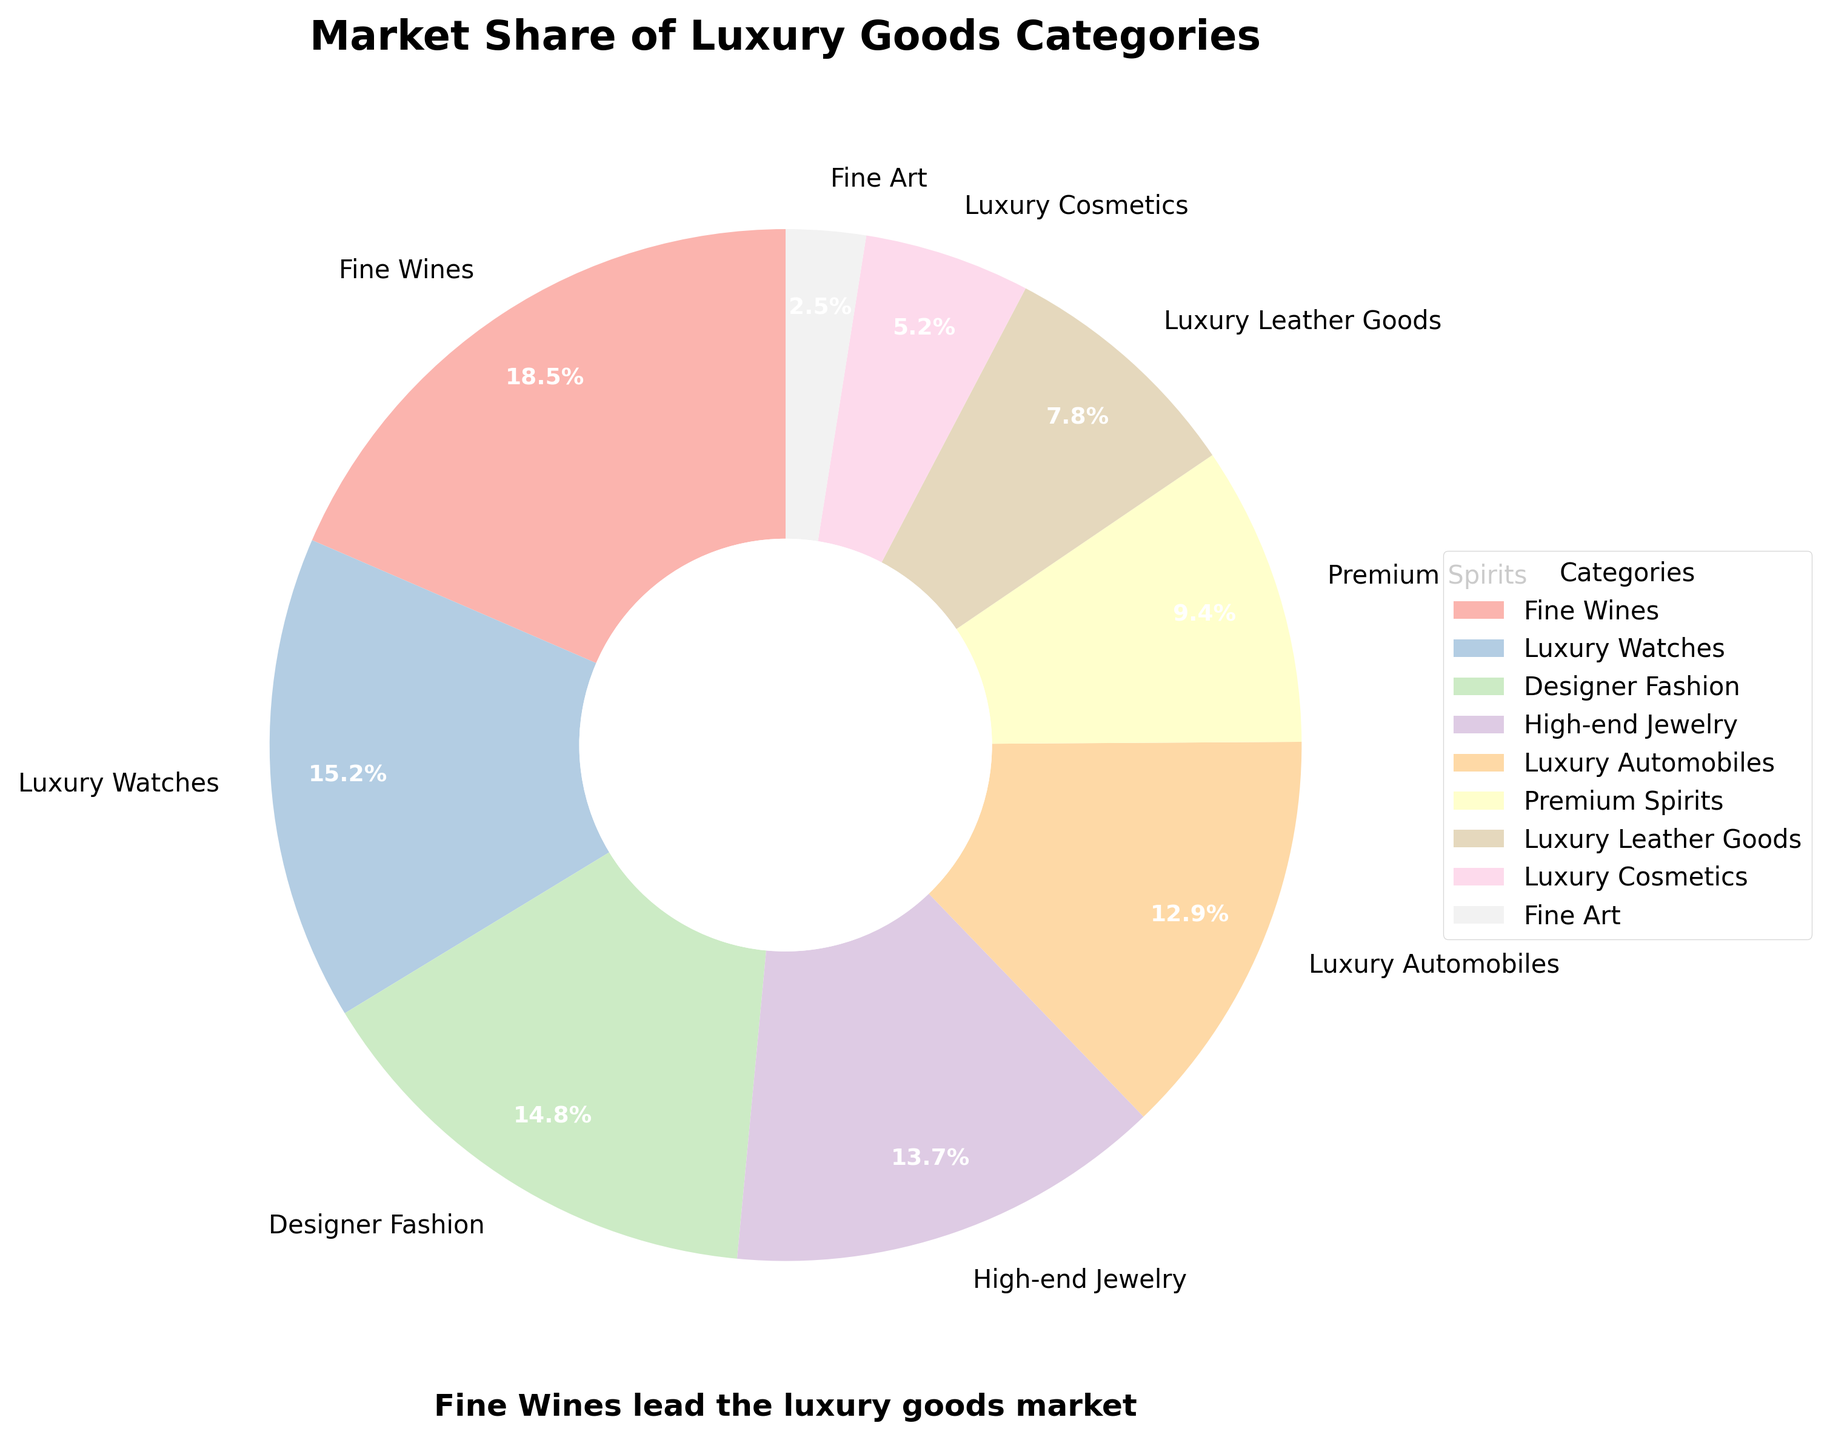Which luxury goods category has the largest market share? The pie chart shows that Fine Wines have the largest market share, represented by the largest wedge in the chart.
Answer: Fine Wines What is the combined market share of Luxury Watches and Designer Fashion? The market share for Luxury Watches is 15.2% and for Designer Fashion is 14.8%. Adding these together gives 15.2% + 14.8% = 30%.
Answer: 30% How much larger is the market share of Fine Wines compared to High-end Jewelry? The market share for Fine Wines is 18.5% and for High-end Jewelry is 13.7%. Subtracting these values gives 18.5% - 13.7% = 4.8%.
Answer: 4.8% Which category has the smallest market share and what is it? The pie chart shows the smallest wedge, which represents Fine Art at 2.5% market share.
Answer: Fine Art, 2.5% Are there any categories with nearly equal market shares? Yes, Designer Fashion (14.8%) and High-end Jewelry (13.7%) have nearly equal market shares, showing similar-sized wedges.
Answer: Designer Fashion and High-end Jewelry What's the total market share of categories related to fashion (Designer Fashion and Luxury Leather Goods)? The market share for Designer Fashion is 14.8% and for Luxury Leather Goods is 7.8%. Adding these together gives 14.8% + 7.8% = 22.6%.
Answer: 22.6% Describe the color used to represent Fine Wines in the pie chart. The pie chart uses colors from a pastel palette. The wedge for Fine Wines is in a pastel color, likely pink or a light shade related to wine.
Answer: Pastel pink What's the difference in market share between Premium Spirits and Luxury Cosmetics? The market share for Premium Spirits is 9.4% and for Luxury Cosmetics is 5.2%. Subtracting these values gives 9.4% - 5.2% = 4.2%.
Answer: 4.2% Which category has a market share that is closest to 10%? The market share closest to 10% is Premium Spirits at 9.4%.
Answer: Premium Spirits What percentage of the market is covered by categories other than Fine Wines? The market share of Fine Wines is 18.5%. Subtracting this from 100% gives the rest of the market, 100% - 18.5% = 81.5%.
Answer: 81.5% 